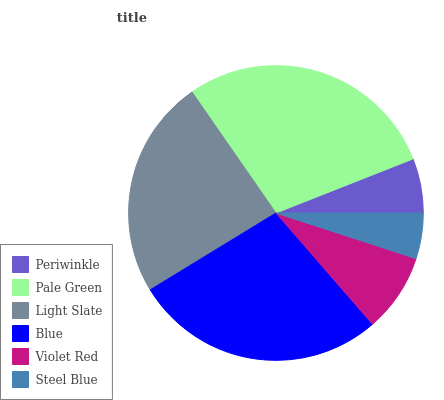Is Steel Blue the minimum?
Answer yes or no. Yes. Is Pale Green the maximum?
Answer yes or no. Yes. Is Light Slate the minimum?
Answer yes or no. No. Is Light Slate the maximum?
Answer yes or no. No. Is Pale Green greater than Light Slate?
Answer yes or no. Yes. Is Light Slate less than Pale Green?
Answer yes or no. Yes. Is Light Slate greater than Pale Green?
Answer yes or no. No. Is Pale Green less than Light Slate?
Answer yes or no. No. Is Light Slate the high median?
Answer yes or no. Yes. Is Violet Red the low median?
Answer yes or no. Yes. Is Steel Blue the high median?
Answer yes or no. No. Is Pale Green the low median?
Answer yes or no. No. 